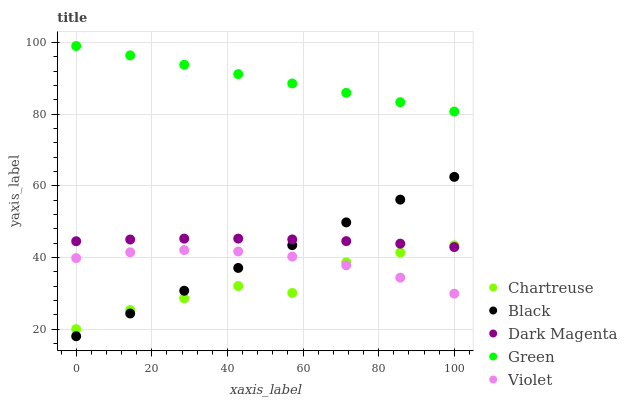Does Chartreuse have the minimum area under the curve?
Answer yes or no. Yes. Does Green have the maximum area under the curve?
Answer yes or no. Yes. Does Black have the minimum area under the curve?
Answer yes or no. No. Does Black have the maximum area under the curve?
Answer yes or no. No. Is Black the smoothest?
Answer yes or no. Yes. Is Chartreuse the roughest?
Answer yes or no. Yes. Is Chartreuse the smoothest?
Answer yes or no. No. Is Black the roughest?
Answer yes or no. No. Does Black have the lowest value?
Answer yes or no. Yes. Does Chartreuse have the lowest value?
Answer yes or no. No. Does Green have the highest value?
Answer yes or no. Yes. Does Chartreuse have the highest value?
Answer yes or no. No. Is Violet less than Dark Magenta?
Answer yes or no. Yes. Is Green greater than Black?
Answer yes or no. Yes. Does Black intersect Violet?
Answer yes or no. Yes. Is Black less than Violet?
Answer yes or no. No. Is Black greater than Violet?
Answer yes or no. No. Does Violet intersect Dark Magenta?
Answer yes or no. No. 